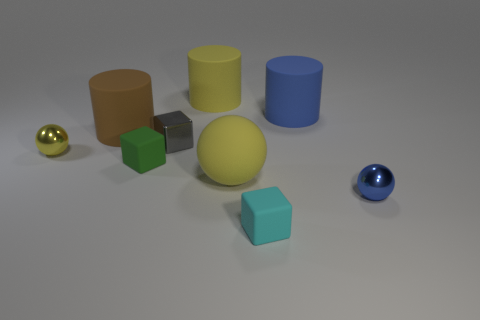Subtract all cylinders. How many objects are left? 6 Subtract all large red rubber cubes. Subtract all large matte objects. How many objects are left? 5 Add 4 big yellow things. How many big yellow things are left? 6 Add 2 small yellow metal balls. How many small yellow metal balls exist? 3 Subtract 0 red cubes. How many objects are left? 9 